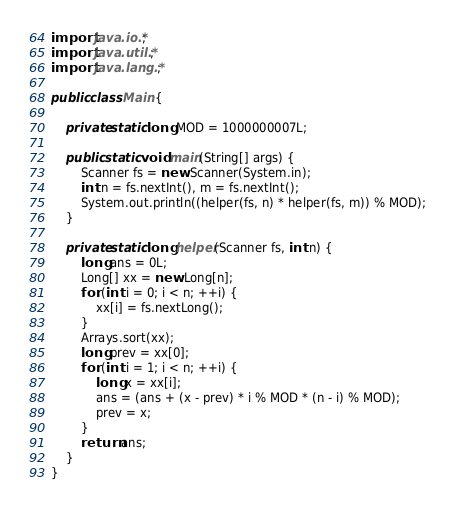Convert code to text. <code><loc_0><loc_0><loc_500><loc_500><_Java_>
import java.io.*;
import java.util.*;
import java.lang.*;

public class Main {

    private static long MOD = 1000000007L;

    public static void main(String[] args) {
        Scanner fs = new Scanner(System.in);
        int n = fs.nextInt(), m = fs.nextInt();
        System.out.println((helper(fs, n) * helper(fs, m)) % MOD);
    }

    private static long helper(Scanner fs, int n) {
        long ans = 0L;
        Long[] xx = new Long[n];
        for (int i = 0; i < n; ++i) {
            xx[i] = fs.nextLong();
        }
        Arrays.sort(xx);
        long prev = xx[0];
        for (int i = 1; i < n; ++i) {
            long x = xx[i];
            ans = (ans + (x - prev) * i % MOD * (n - i) % MOD);
            prev = x;
        }
        return ans;
    }
}
</code> 